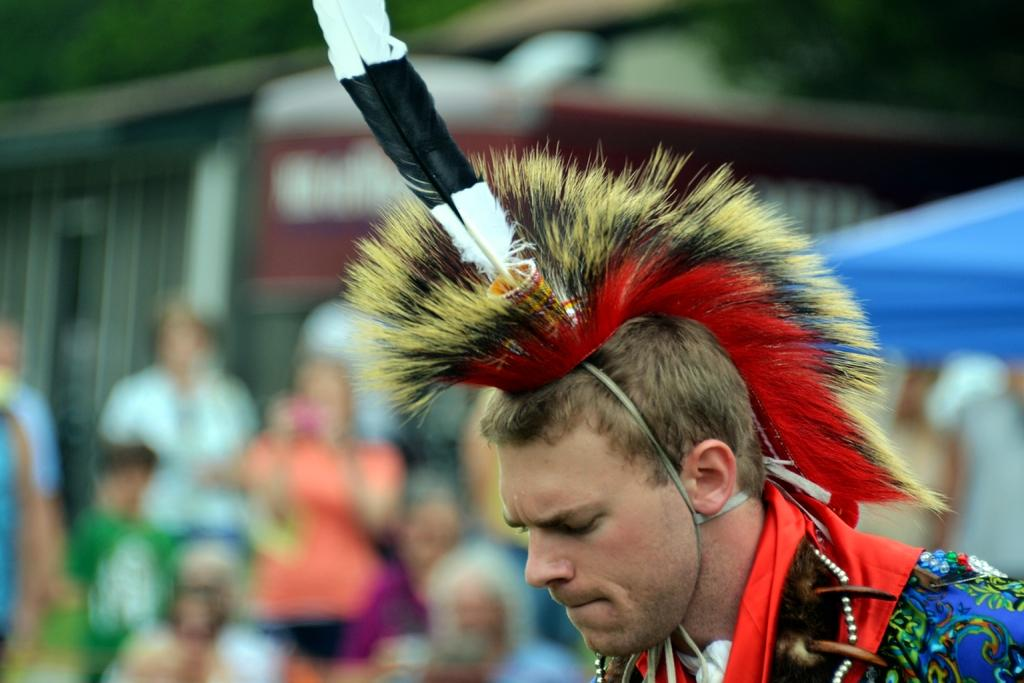Who or what can be seen on the right side of the image? There is a person present on the right side of the image. What is the person wearing in the image? The person is wearing a dress. Can you describe the background of the image? The background of the image is blurred. What type of kite is the person holding in the image? There is no kite present in the image; the person is wearing a dress and standing in a blurred background. 